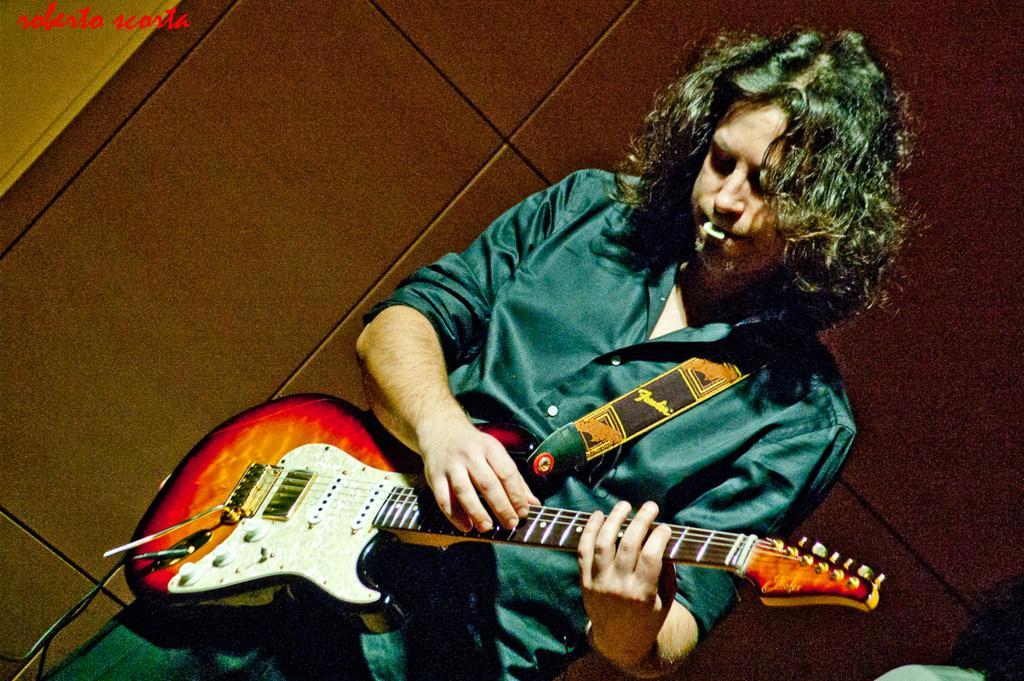How would you summarize this image in a sentence or two? Here we can see one man with short hair, standing and playing a guitar. We can see a coin in his mouth. 